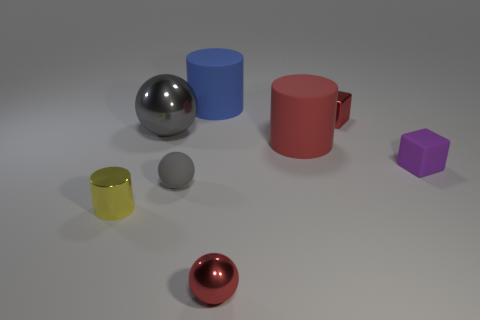Is there any other thing that is the same size as the blue object?
Offer a very short reply. Yes. There is a big cylinder that is to the right of the blue rubber cylinder; is there a block that is to the left of it?
Give a very brief answer. No. Is the red block made of the same material as the red cylinder?
Offer a very short reply. No. There is a thing that is both in front of the gray matte thing and on the left side of the large blue matte cylinder; what shape is it?
Provide a succinct answer. Cylinder. There is a rubber thing that is behind the small red thing that is behind the yellow thing; what is its size?
Your answer should be very brief. Large. What number of tiny purple objects have the same shape as the small yellow thing?
Make the answer very short. 0. Do the large metallic thing and the small metallic block have the same color?
Your answer should be compact. No. Are there any other things that have the same shape as the blue thing?
Your answer should be very brief. Yes. Are there any big matte cylinders of the same color as the metal cube?
Provide a succinct answer. Yes. Are the small ball behind the tiny shiny cylinder and the gray sphere behind the small purple cube made of the same material?
Provide a succinct answer. No. 